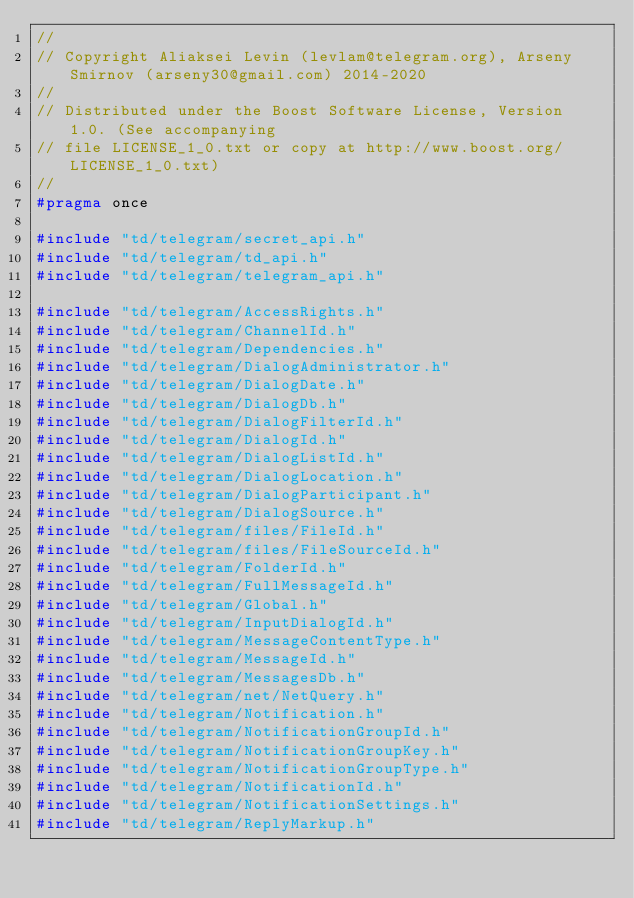Convert code to text. <code><loc_0><loc_0><loc_500><loc_500><_C_>//
// Copyright Aliaksei Levin (levlam@telegram.org), Arseny Smirnov (arseny30@gmail.com) 2014-2020
//
// Distributed under the Boost Software License, Version 1.0. (See accompanying
// file LICENSE_1_0.txt or copy at http://www.boost.org/LICENSE_1_0.txt)
//
#pragma once

#include "td/telegram/secret_api.h"
#include "td/telegram/td_api.h"
#include "td/telegram/telegram_api.h"

#include "td/telegram/AccessRights.h"
#include "td/telegram/ChannelId.h"
#include "td/telegram/Dependencies.h"
#include "td/telegram/DialogAdministrator.h"
#include "td/telegram/DialogDate.h"
#include "td/telegram/DialogDb.h"
#include "td/telegram/DialogFilterId.h"
#include "td/telegram/DialogId.h"
#include "td/telegram/DialogListId.h"
#include "td/telegram/DialogLocation.h"
#include "td/telegram/DialogParticipant.h"
#include "td/telegram/DialogSource.h"
#include "td/telegram/files/FileId.h"
#include "td/telegram/files/FileSourceId.h"
#include "td/telegram/FolderId.h"
#include "td/telegram/FullMessageId.h"
#include "td/telegram/Global.h"
#include "td/telegram/InputDialogId.h"
#include "td/telegram/MessageContentType.h"
#include "td/telegram/MessageId.h"
#include "td/telegram/MessagesDb.h"
#include "td/telegram/net/NetQuery.h"
#include "td/telegram/Notification.h"
#include "td/telegram/NotificationGroupId.h"
#include "td/telegram/NotificationGroupKey.h"
#include "td/telegram/NotificationGroupType.h"
#include "td/telegram/NotificationId.h"
#include "td/telegram/NotificationSettings.h"
#include "td/telegram/ReplyMarkup.h"</code> 